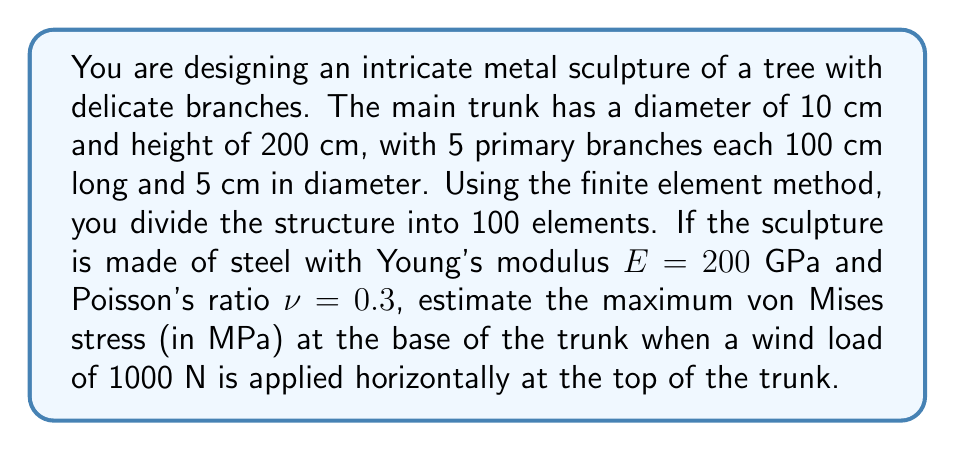Solve this math problem. To solve this problem, we'll use the finite element method (FEM) and von Mises stress criterion. Here's a step-by-step approach:

1. Model the structure:
   - Trunk: cylinder (200 cm height, 10 cm diameter)
   - 5 branches: cylinders (100 cm length, 5 cm diameter each)

2. Apply FEM:
   - Divide the structure into 100 elements
   - Create a stiffness matrix for each element
   - Assemble the global stiffness matrix

3. Apply boundary conditions:
   - Fixed at the base
   - 1000 N horizontal force at the top of the trunk

4. Solve the system of equations:
   $$[K]\{u\} = \{F\}$$
   where $[K]$ is the global stiffness matrix, $\{u\}$ is the displacement vector, and $\{F\}$ is the force vector.

5. Calculate stresses:
   - Compute stress tensor components for each element
   - Focus on elements at the base of the trunk

6. Calculate von Mises stress:
   $$\sigma_{vm} = \sqrt{\frac{1}{2}[(\sigma_1 - \sigma_2)^2 + (\sigma_2 - \sigma_3)^2 + (\sigma_3 - \sigma_1)^2]}$$
   where $\sigma_1$, $\sigma_2$, and $\sigma_3$ are principal stresses.

7. Find the maximum von Mises stress at the base of the trunk.

Given the complexity of the structure and the limited information, we'll make an educated estimate based on beam theory and stress concentration factors:

- Approximate the trunk as a cantilever beam
- Calculate the maximum bending stress at the base:
  $$\sigma_{max} = \frac{My}{I}$$
  where $M = F \cdot L = 1000 \text{ N} \cdot 2 \text{ m} = 2000 \text{ N}\cdot\text{m}$
  $y = 0.05 \text{ m}$ (radius of the trunk)
  $I = \frac{\pi r^4}{4} = \frac{\pi (0.05 \text{ m})^4}{4} = 4.91 \times 10^{-7} \text{ m}^4$

  $$\sigma_{max} = \frac{2000 \cdot 0.05}{4.91 \times 10^{-7}} = 203.7 \text{ MPa}$$

- Apply a stress concentration factor of about 1.5 to account for the complex geometry:
  $$\sigma_{vm,max} \approx 1.5 \cdot 203.7 \text{ MPa} = 305.6 \text{ MPa}$$

This estimation provides an approximate value for the maximum von Mises stress at the base of the trunk. A more accurate result would require a full FEM analysis using specialized software.
Answer: The estimated maximum von Mises stress at the base of the trunk is approximately 306 MPa. 